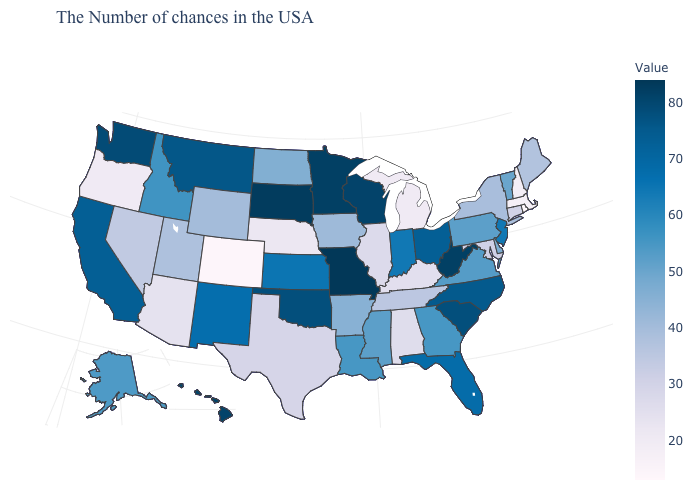Which states have the lowest value in the USA?
Be succinct. Rhode Island. Which states have the lowest value in the USA?
Answer briefly. Rhode Island. Which states have the lowest value in the Northeast?
Answer briefly. Rhode Island. Does Rhode Island have the lowest value in the USA?
Write a very short answer. Yes. Which states have the highest value in the USA?
Keep it brief. Missouri. Does Washington have a lower value than Virginia?
Keep it brief. No. 